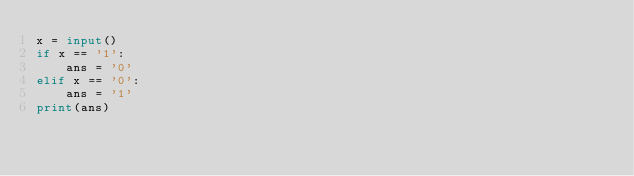<code> <loc_0><loc_0><loc_500><loc_500><_Python_>x = input()
if x == '1':
    ans = '0'
elif x == '0':
    ans = '1'
print(ans)</code> 